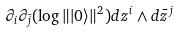<formula> <loc_0><loc_0><loc_500><loc_500>\partial _ { i } \partial _ { \bar { j } } ( \log \| | 0 \rangle \| ^ { 2 } ) d z ^ { i } \wedge d { \bar { z } } ^ { j }</formula> 